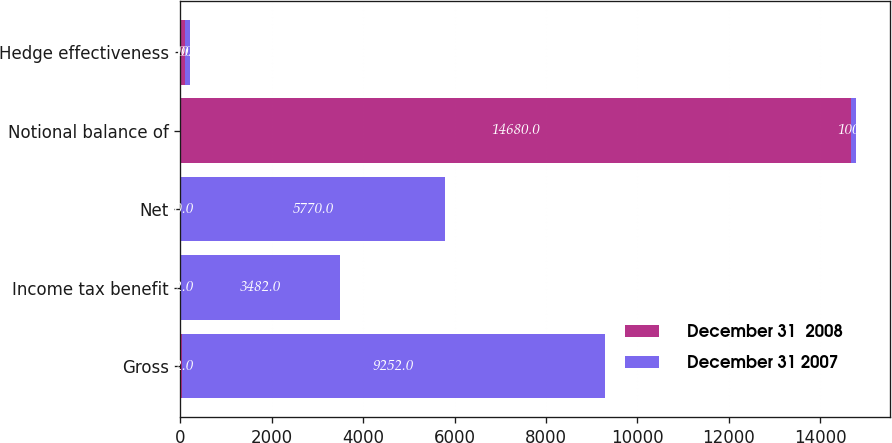Convert chart. <chart><loc_0><loc_0><loc_500><loc_500><stacked_bar_chart><ecel><fcel>Gross<fcel>Income tax benefit<fcel>Net<fcel>Notional balance of<fcel>Hedge effectiveness<nl><fcel>December 31  2008<fcel>32<fcel>12<fcel>20<fcel>14680<fcel>100<nl><fcel>December 31 2007<fcel>9252<fcel>3482<fcel>5770<fcel>100<fcel>100<nl></chart> 